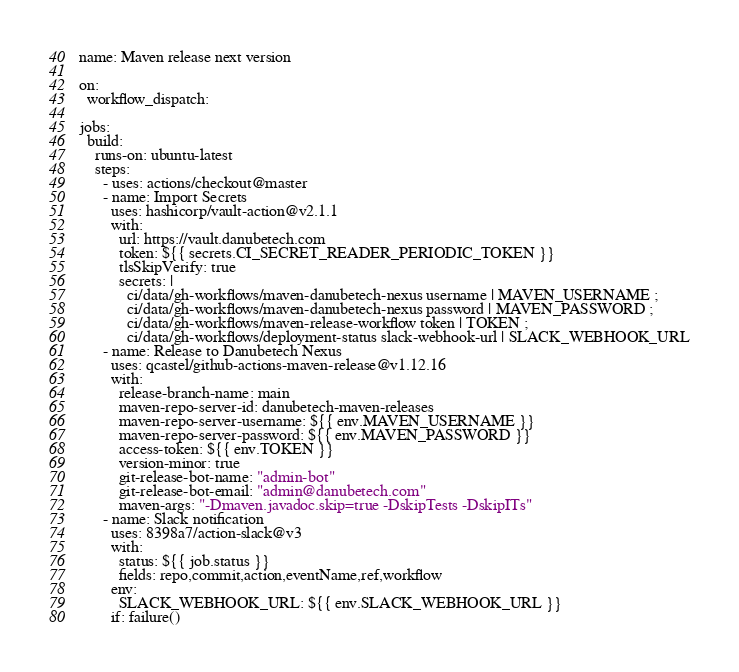Convert code to text. <code><loc_0><loc_0><loc_500><loc_500><_YAML_>name: Maven release next version

on:
  workflow_dispatch:

jobs:
  build:
    runs-on: ubuntu-latest
    steps:
      - uses: actions/checkout@master
      - name: Import Secrets
        uses: hashicorp/vault-action@v2.1.1
        with:
          url: https://vault.danubetech.com
          token: ${{ secrets.CI_SECRET_READER_PERIODIC_TOKEN }}
          tlsSkipVerify: true
          secrets: |
            ci/data/gh-workflows/maven-danubetech-nexus username | MAVEN_USERNAME ;
            ci/data/gh-workflows/maven-danubetech-nexus password | MAVEN_PASSWORD ;
            ci/data/gh-workflows/maven-release-workflow token | TOKEN ;
            ci/data/gh-workflows/deployment-status slack-webhook-url | SLACK_WEBHOOK_URL
      - name: Release to Danubetech Nexus
        uses: qcastel/github-actions-maven-release@v1.12.16
        with:
          release-branch-name: main
          maven-repo-server-id: danubetech-maven-releases
          maven-repo-server-username: ${{ env.MAVEN_USERNAME }}
          maven-repo-server-password: ${{ env.MAVEN_PASSWORD }}
          access-token: ${{ env.TOKEN }}
          version-minor: true
          git-release-bot-name: "admin-bot"
          git-release-bot-email: "admin@danubetech.com"
          maven-args: "-Dmaven.javadoc.skip=true -DskipTests -DskipITs"
      - name: Slack notification
        uses: 8398a7/action-slack@v3
        with:
          status: ${{ job.status }}
          fields: repo,commit,action,eventName,ref,workflow
        env:
          SLACK_WEBHOOK_URL: ${{ env.SLACK_WEBHOOK_URL }}
        if: failure()
</code> 